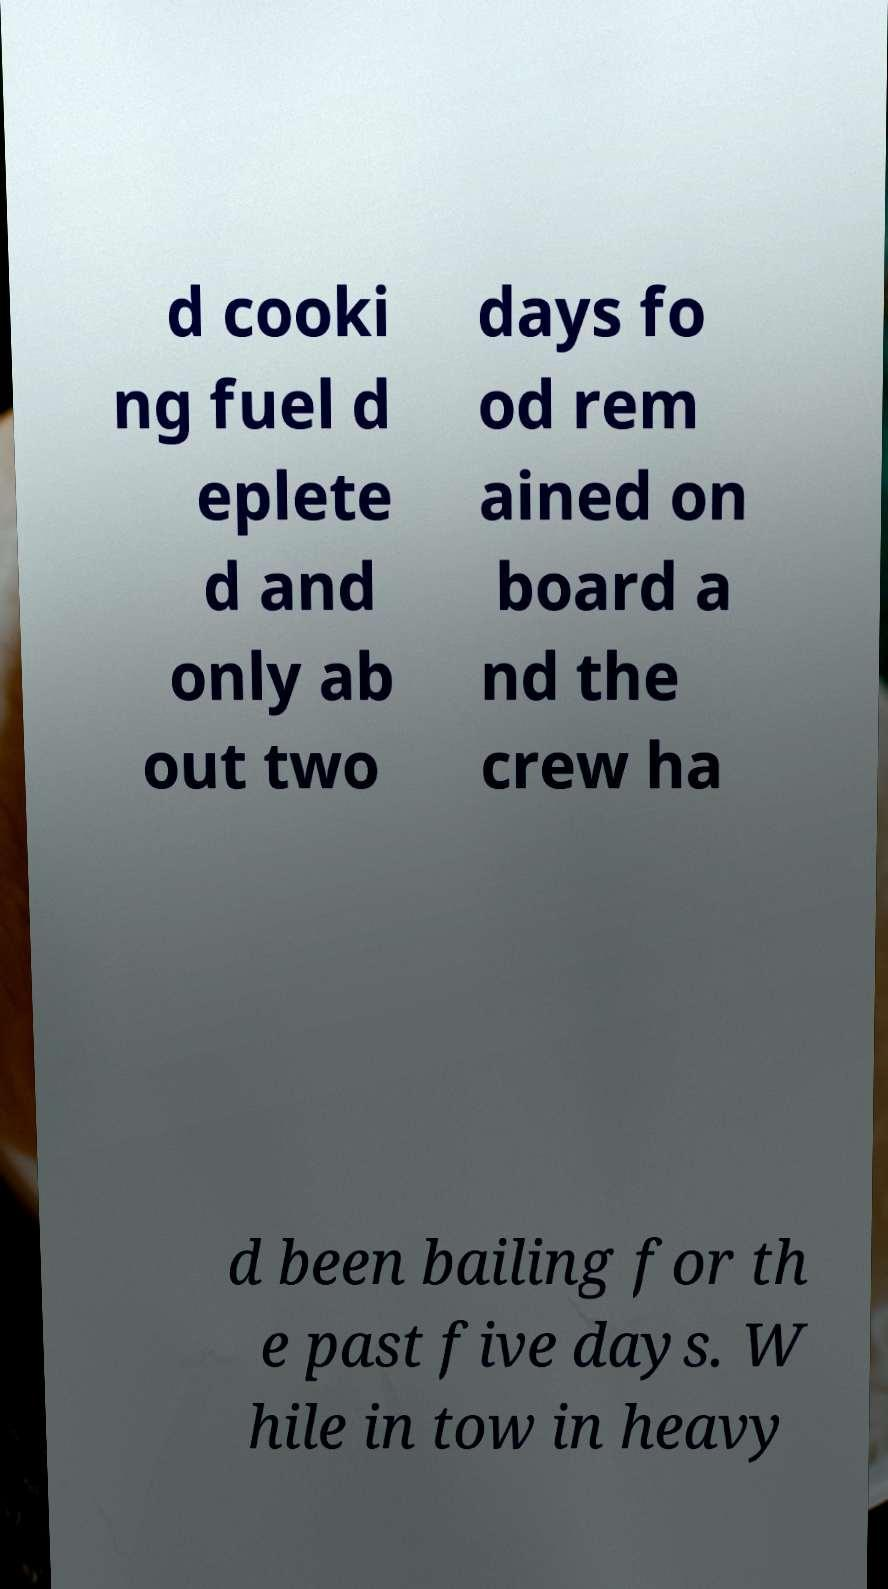For documentation purposes, I need the text within this image transcribed. Could you provide that? d cooki ng fuel d eplete d and only ab out two days fo od rem ained on board a nd the crew ha d been bailing for th e past five days. W hile in tow in heavy 